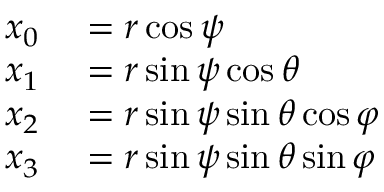Convert formula to latex. <formula><loc_0><loc_0><loc_500><loc_500>\begin{array} { r l } { x _ { 0 } } & = r \cos \psi } \\ { x _ { 1 } } & = r \sin \psi \cos \theta } \\ { x _ { 2 } } & = r \sin \psi \sin \theta \cos \varphi } \\ { x _ { 3 } } & = r \sin \psi \sin \theta \sin \varphi } \end{array}</formula> 